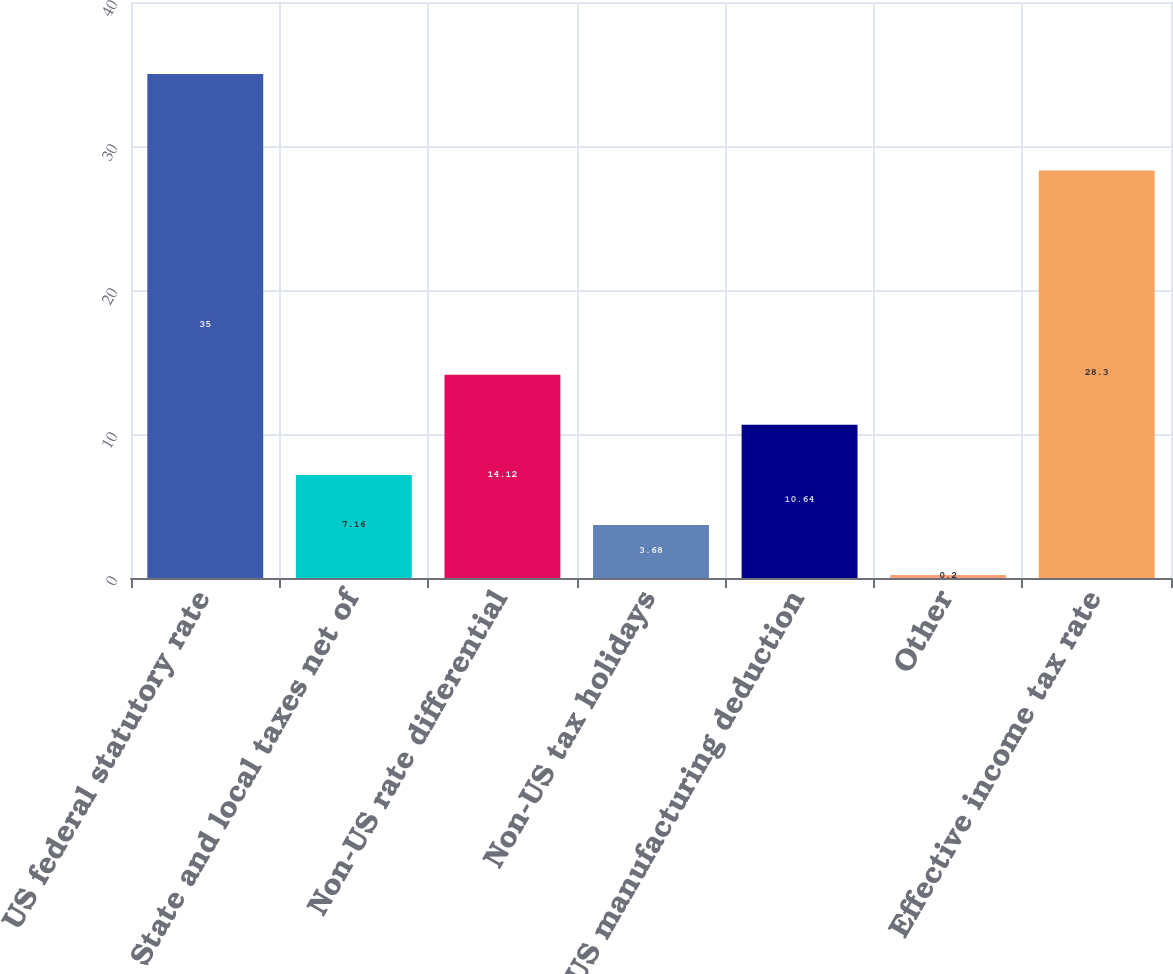Convert chart. <chart><loc_0><loc_0><loc_500><loc_500><bar_chart><fcel>US federal statutory rate<fcel>State and local taxes net of<fcel>Non-US rate differential<fcel>Non-US tax holidays<fcel>US manufacturing deduction<fcel>Other<fcel>Effective income tax rate<nl><fcel>35<fcel>7.16<fcel>14.12<fcel>3.68<fcel>10.64<fcel>0.2<fcel>28.3<nl></chart> 